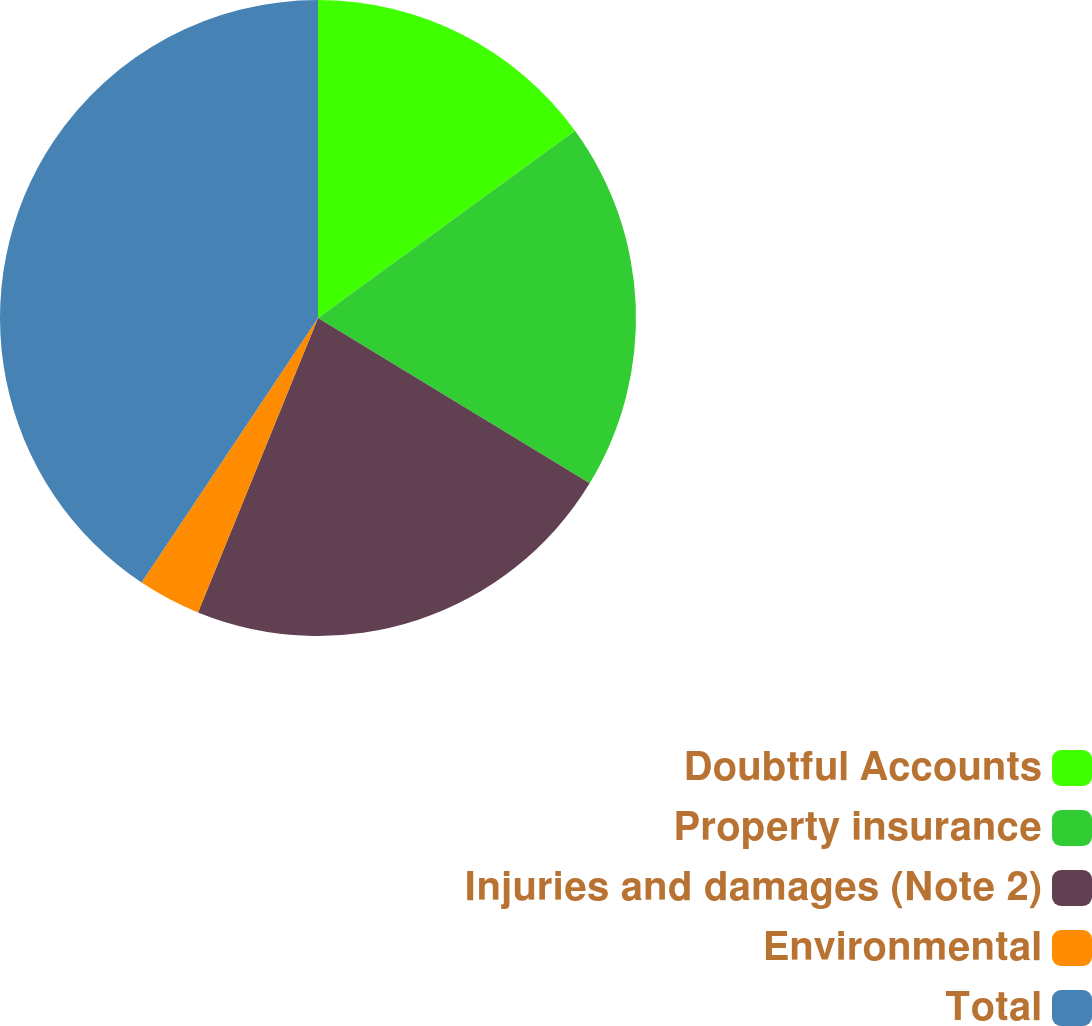<chart> <loc_0><loc_0><loc_500><loc_500><pie_chart><fcel>Doubtful Accounts<fcel>Property insurance<fcel>Injuries and damages (Note 2)<fcel>Environmental<fcel>Total<nl><fcel>14.98%<fcel>18.72%<fcel>22.46%<fcel>3.2%<fcel>40.64%<nl></chart> 